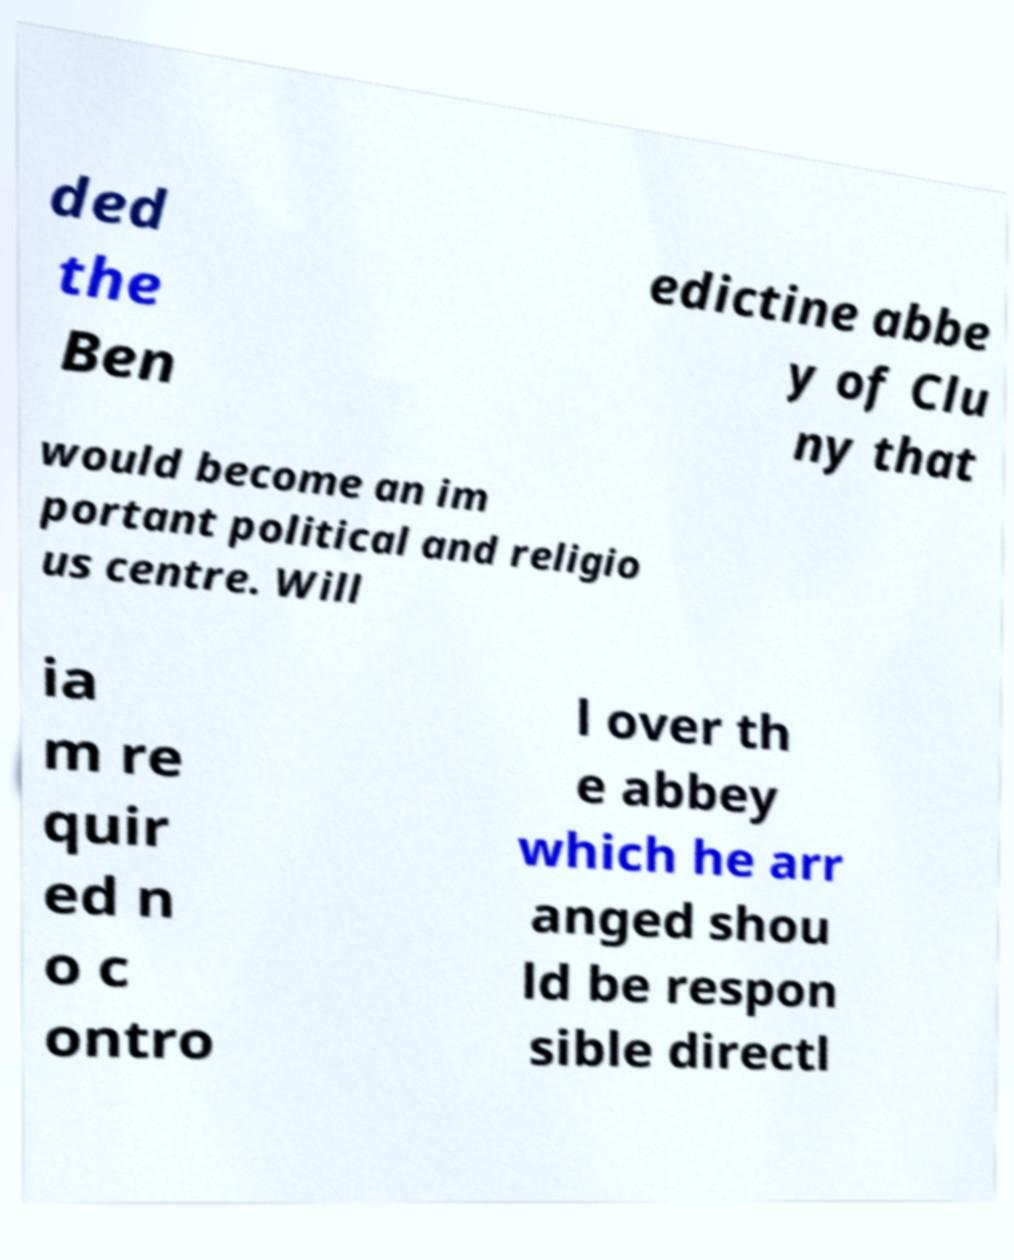Can you accurately transcribe the text from the provided image for me? ded the Ben edictine abbe y of Clu ny that would become an im portant political and religio us centre. Will ia m re quir ed n o c ontro l over th e abbey which he arr anged shou ld be respon sible directl 